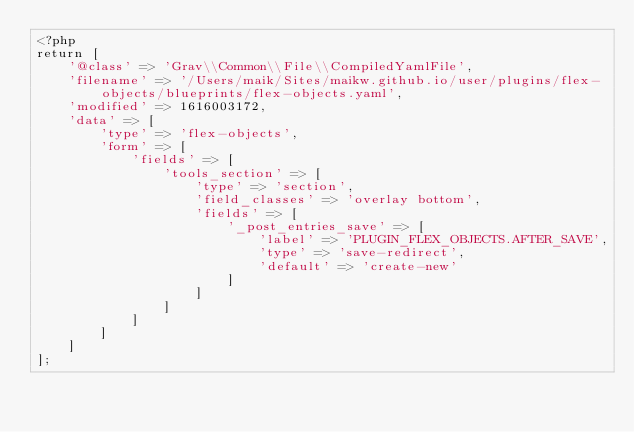Convert code to text. <code><loc_0><loc_0><loc_500><loc_500><_PHP_><?php
return [
    '@class' => 'Grav\\Common\\File\\CompiledYamlFile',
    'filename' => '/Users/maik/Sites/maikw.github.io/user/plugins/flex-objects/blueprints/flex-objects.yaml',
    'modified' => 1616003172,
    'data' => [
        'type' => 'flex-objects',
        'form' => [
            'fields' => [
                'tools_section' => [
                    'type' => 'section',
                    'field_classes' => 'overlay bottom',
                    'fields' => [
                        '_post_entries_save' => [
                            'label' => 'PLUGIN_FLEX_OBJECTS.AFTER_SAVE',
                            'type' => 'save-redirect',
                            'default' => 'create-new'
                        ]
                    ]
                ]
            ]
        ]
    ]
];
</code> 